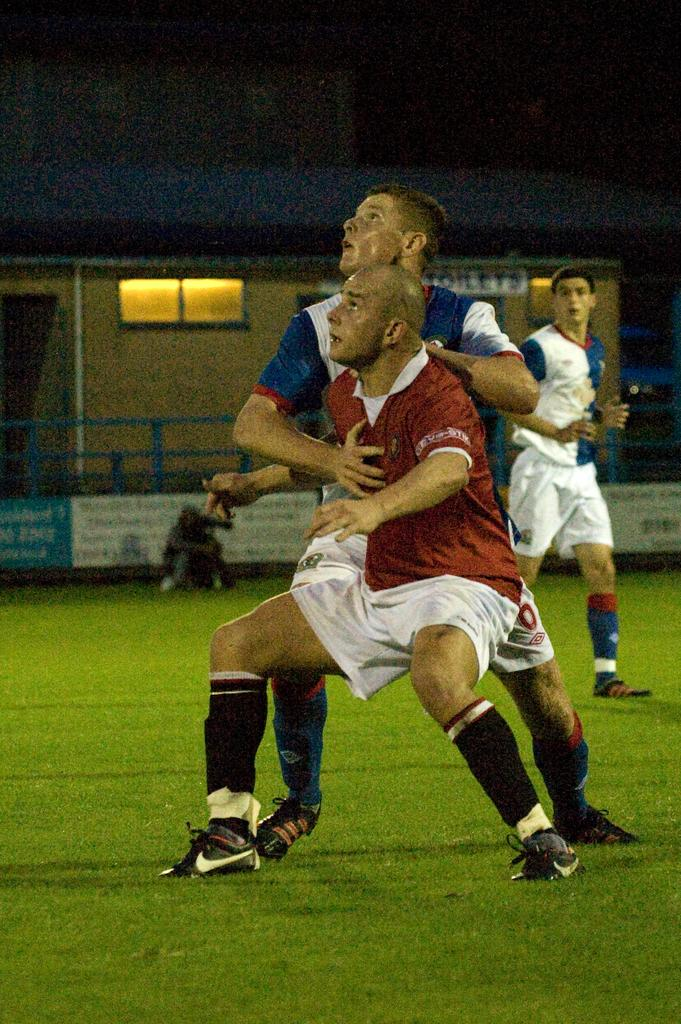What can be seen on the ground in the image? There are people on the ground in the image. What structures can be seen in the background of the image? There is a shed, a board, and a fence in the background of the image. What can be seen illuminated in the image? There are lights visible in the image. What else is present in the image besides the people and structures? There are some objects present in the image. What type of jewel is being used to control the impulse of the people in the image? There is no jewel or any indication of controlling impulses in the image; it simply shows people on the ground and various structures and objects. 